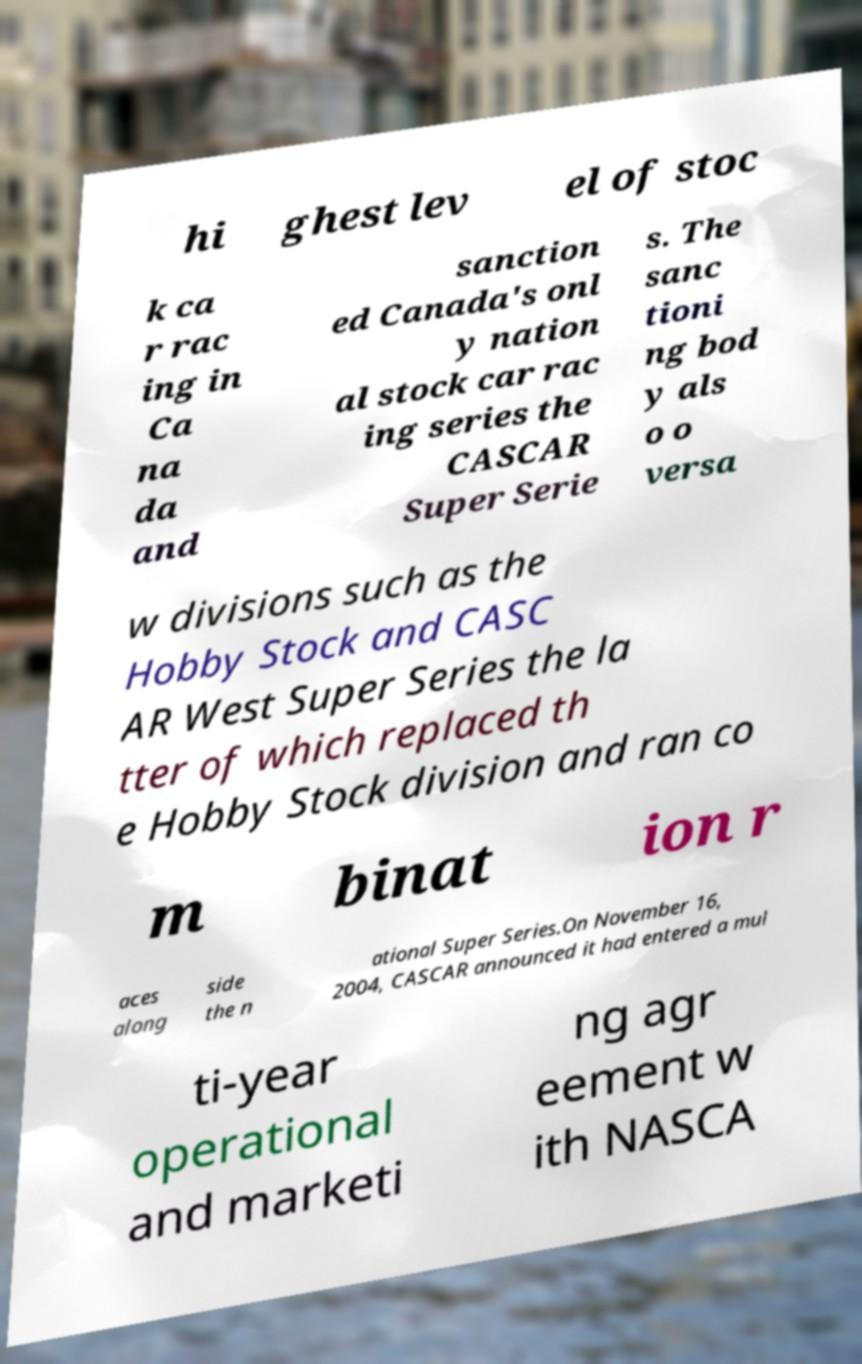Could you assist in decoding the text presented in this image and type it out clearly? hi ghest lev el of stoc k ca r rac ing in Ca na da and sanction ed Canada's onl y nation al stock car rac ing series the CASCAR Super Serie s. The sanc tioni ng bod y als o o versa w divisions such as the Hobby Stock and CASC AR West Super Series the la tter of which replaced th e Hobby Stock division and ran co m binat ion r aces along side the n ational Super Series.On November 16, 2004, CASCAR announced it had entered a mul ti-year operational and marketi ng agr eement w ith NASCA 